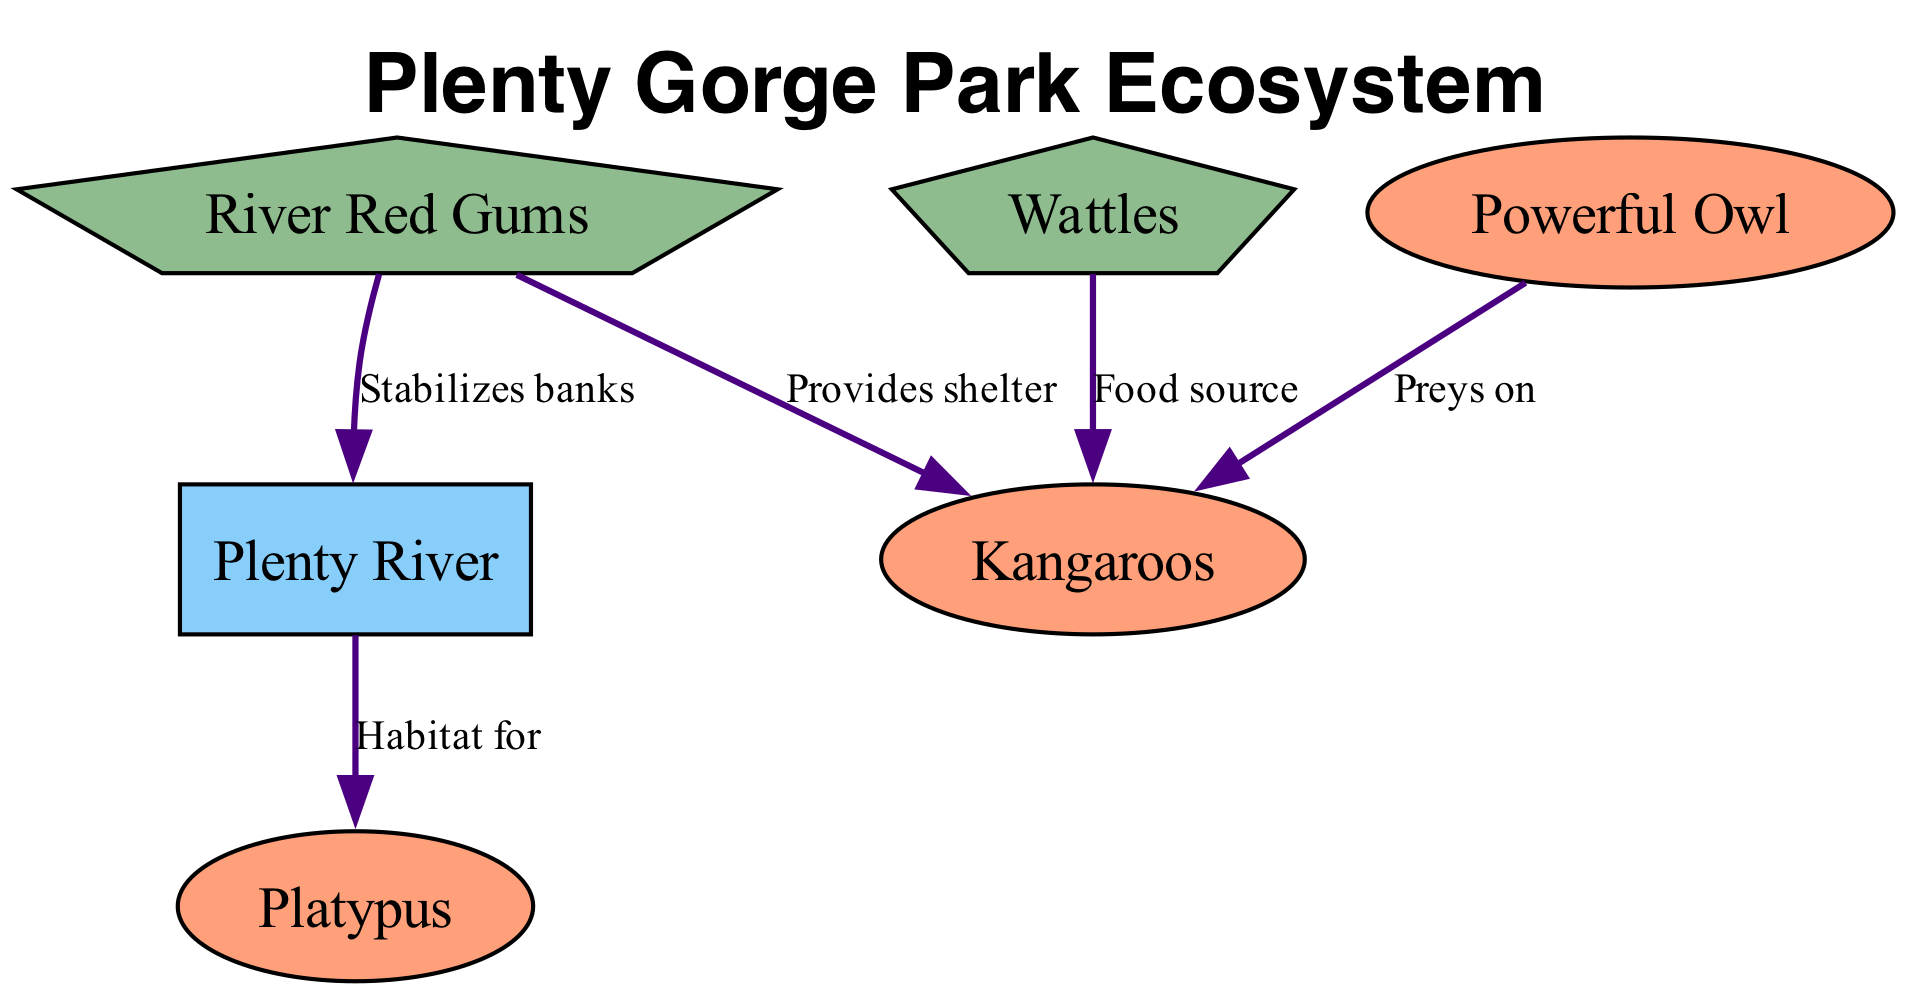What plants provide shelter for kangaroos? The diagram shows that River Red Gums provide shelter for kangaroos, as indicated by the edge labeled "Provides shelter" pointing from River Red Gums to Kangaroos.
Answer: River Red Gums How many fauna nodes are present in the diagram? There are three fauna nodes: Kangaroos, Platypus, and Powerful Owl. Counting these nodes gives us the total number of fauna present.
Answer: 3 What is the relationship between Wattles and Kangaroos? The edge labeled "Food source" from Wattles to Kangaroos indicates that Wattles serve as a food source for kangaroos.
Answer: Food source Which habitat is shown in the diagram? The diagram includes one habitat labeled "Plenty River," which is specifically highlighted in the habitat category of nodes.
Answer: Plenty River Who preys on kangaroos in the ecosystem? The Powerful Owl preys on kangaroos, as demonstrated by the edge labeled "Preys on," which connects Powerful Owl to Kangaroos in the diagram.
Answer: Powerful Owl What is the function of River Red Gums in relation to the banks of the river? River Red Gums stabilize the banks of the river, as indicated by the edge labeled "Stabilizes banks," pointing from River Red Gums to Plenty River.
Answer: Stabilizes banks How does the Plenty River support the Platypus? The Plenty River serves as a habitat for the Platypus, indicated by the edge labeled "Habitat for" which connects Plenty River to Platypus.
Answer: Habitat for What type of plant is Wattles classified as? Wattles are classified as Flora, as noted in the node description that identifies the type associated with Wattles.
Answer: Flora Which fauna species utilizes the Plenty River as habitat? The diagram indicates that the Platypus utilizes the Plenty River as habitat, as shown by the specified relation in the edge labeled "Habitat for."
Answer: Platypus 